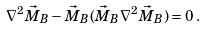<formula> <loc_0><loc_0><loc_500><loc_500>\nabla ^ { 2 } \vec { M } _ { B } - \vec { M } _ { B } ( \vec { M } _ { B } \nabla ^ { 2 } \vec { M } _ { B } ) = 0 \, .</formula> 